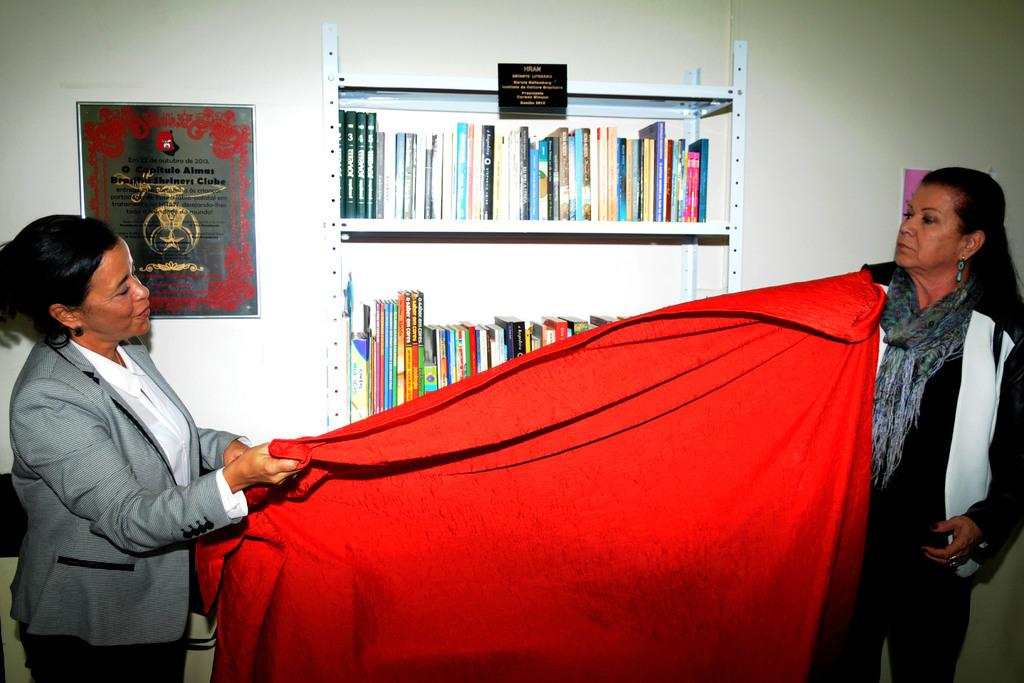How many women are present in the image? There are two women in the image. What are the women doing in the image? The women are standing and holding a cloth. What can be seen on the shelf in the image? There is a shelf with books in the image. What is attached to the wall in the image? There is a frame attached to the wall in the image. What type of steel is used to construct the frame in the image? There is no mention of steel in the image, as the frame is not described in terms of its construction material. 